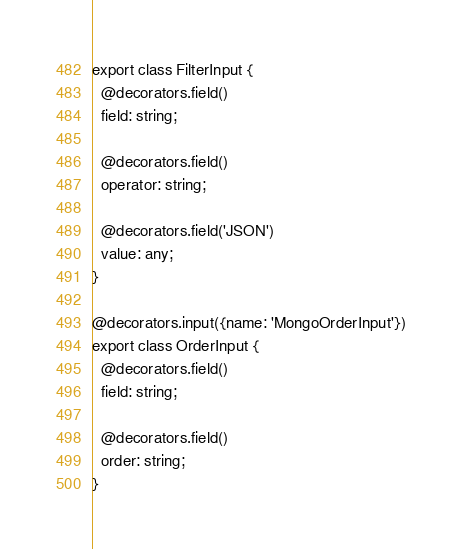Convert code to text. <code><loc_0><loc_0><loc_500><loc_500><_TypeScript_>export class FilterInput {
  @decorators.field()
  field: string;

  @decorators.field()
  operator: string;

  @decorators.field('JSON')
  value: any;
}

@decorators.input({name: 'MongoOrderInput'})
export class OrderInput {
  @decorators.field()
  field: string;

  @decorators.field()
  order: string;
}
</code> 